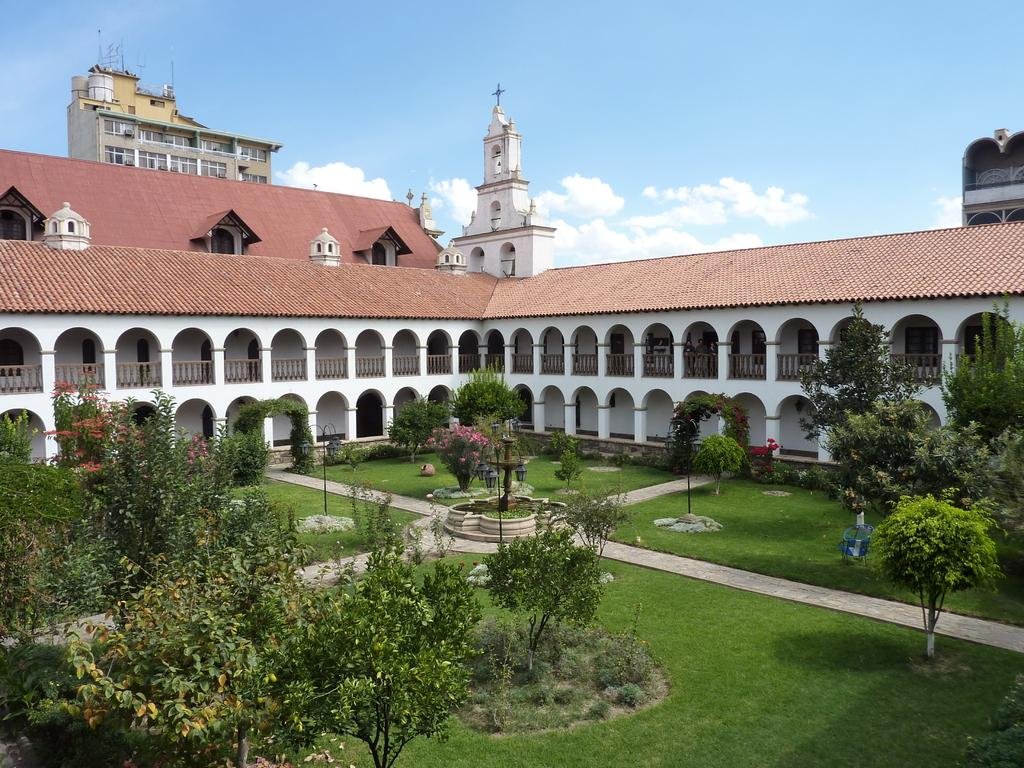What type of vegetation can be seen in the image? There are trees in the image. What kind of path is visible in the image? There is a walkway in the image. What type of lighting is present in the image? There are lamps in the image. What water feature can be seen in the image? There is a fountain in the image. What type of structure is visible in the background of the image? There is a building and a church in the background of the image. What is the condition of the sky in the background of the image? The sky is clear in the background of the image. How many boats are docked near the church in the image? There are no boats present in the image; it features trees, a walkway, lamps, a fountain, a building, a church, and a clear sky. What type of stocking is hanging from the tree in the image? There is no stocking hanging from the tree in the image; it only features trees, a walkway, lamps, a fountain, a building, a church, and a clear sky. 